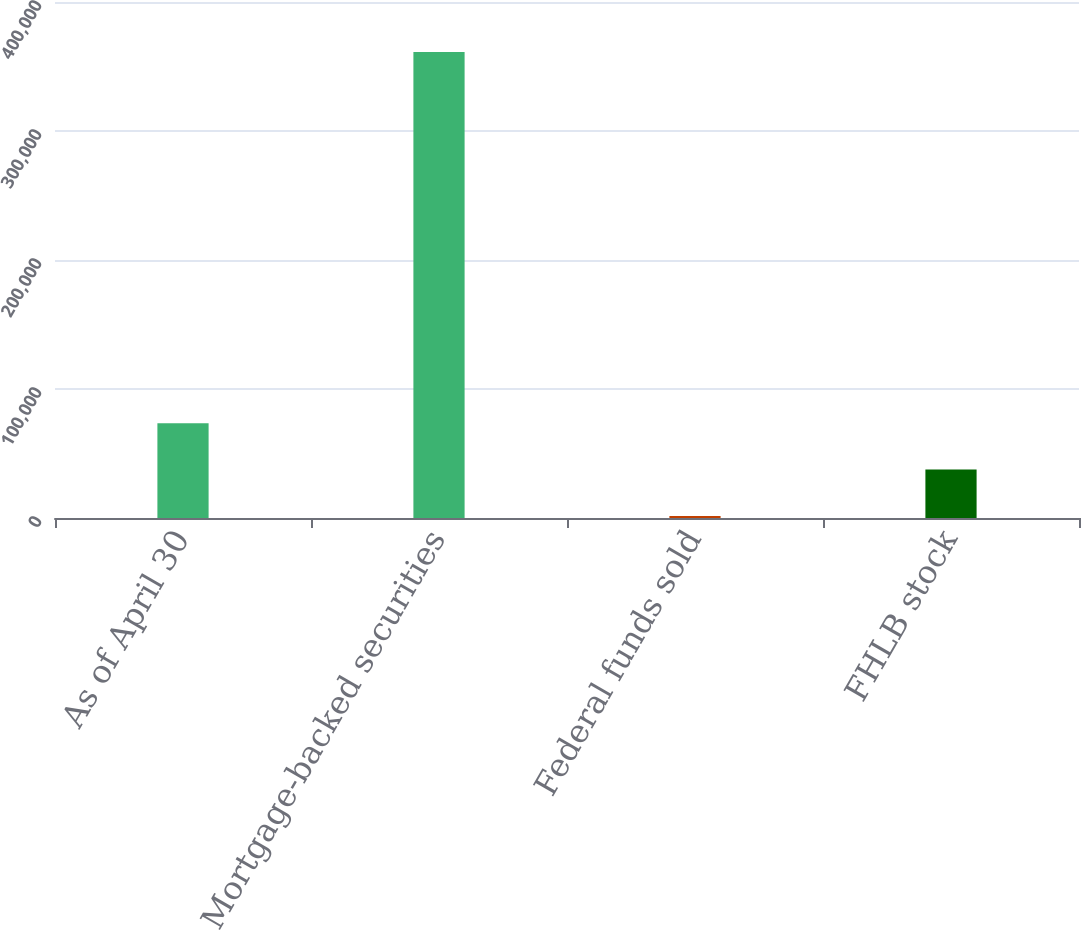Convert chart to OTSL. <chart><loc_0><loc_0><loc_500><loc_500><bar_chart><fcel>As of April 30<fcel>Mortgage-backed securities<fcel>Federal funds sold<fcel>FHLB stock<nl><fcel>73505.6<fcel>361184<fcel>1586<fcel>37545.8<nl></chart> 